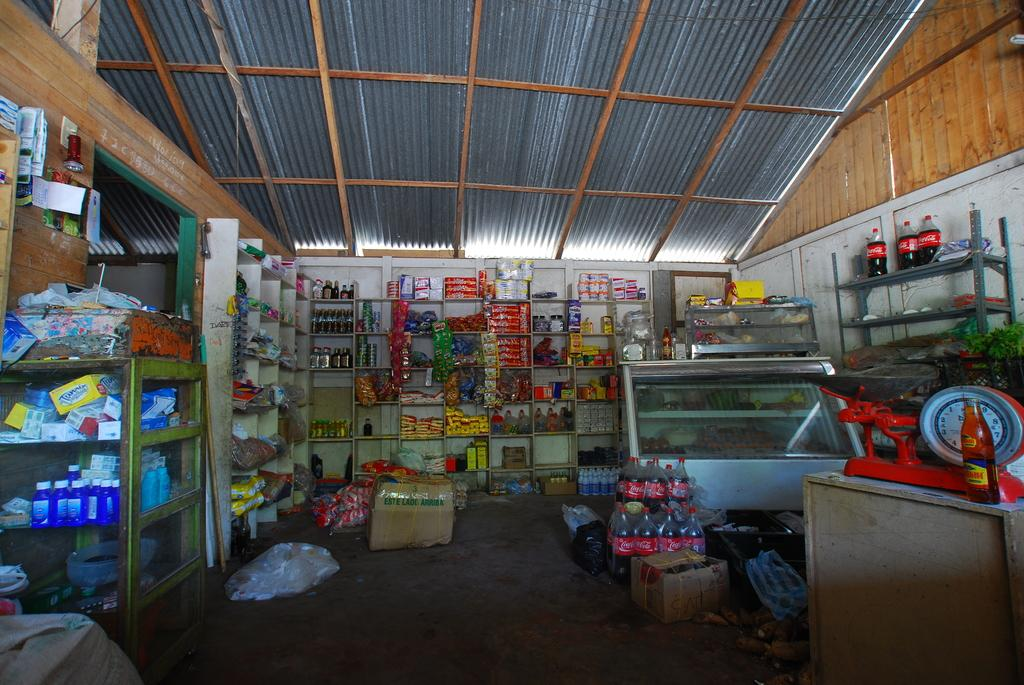<image>
Relay a brief, clear account of the picture shown. A store which has several bottles of Coca Cola stored towards the back. 